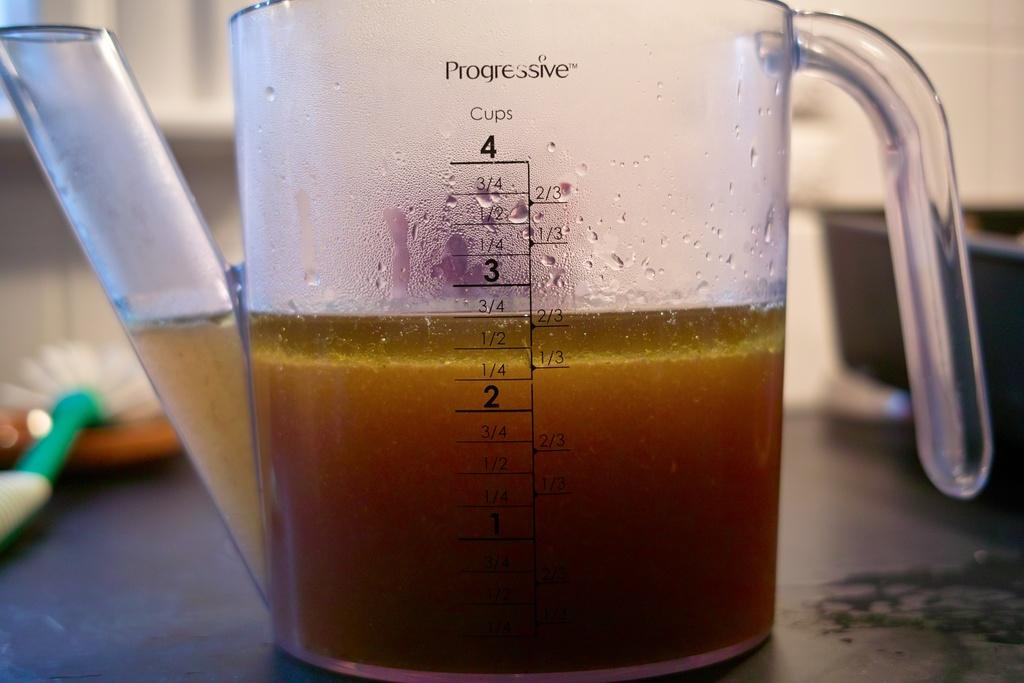Provide a one-sentence caption for the provided image. progressive 4 cup measuring cup with 2 3/4 cups of yellowish-brown liquid in it. 